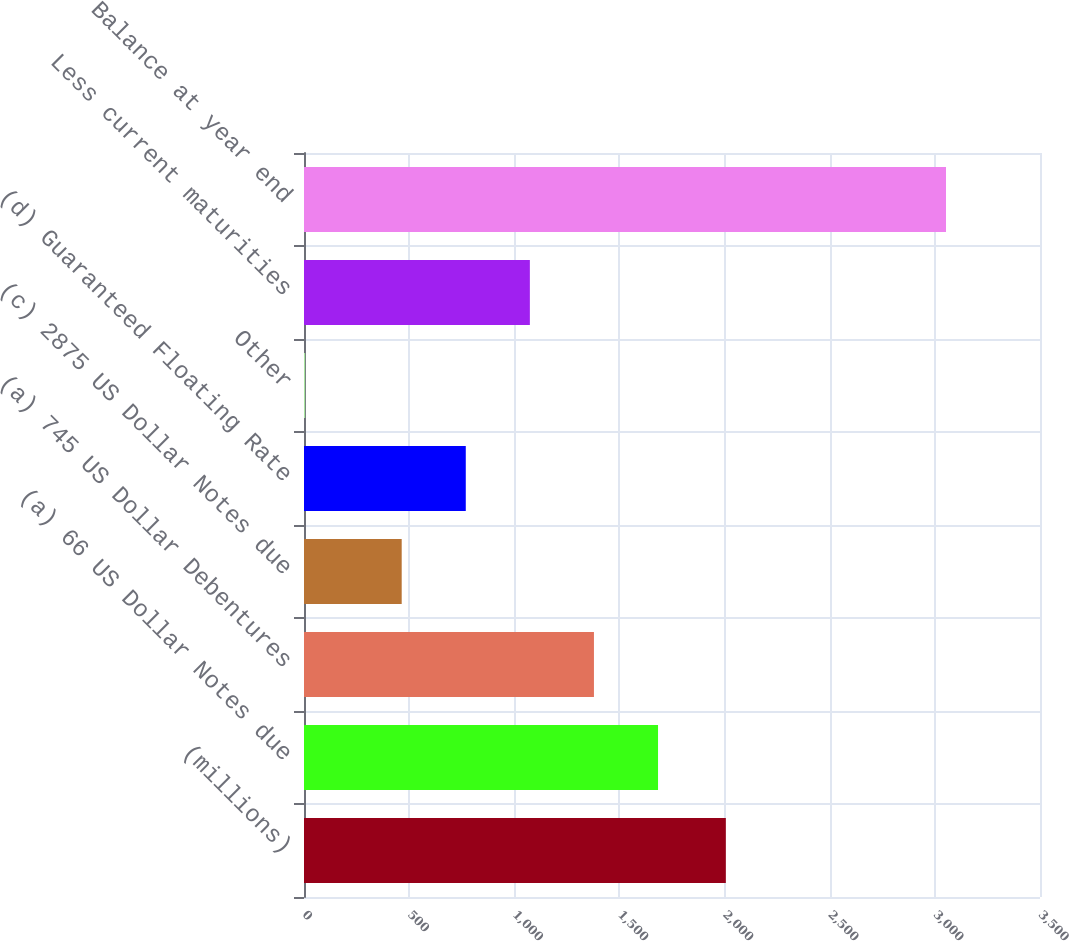Convert chart to OTSL. <chart><loc_0><loc_0><loc_500><loc_500><bar_chart><fcel>(millions)<fcel>(a) 66 US Dollar Notes due<fcel>(a) 745 US Dollar Debentures<fcel>(c) 2875 US Dollar Notes due<fcel>(d) Guaranteed Floating Rate<fcel>Other<fcel>Less current maturities<fcel>Balance at year end<nl><fcel>2006<fcel>1683.56<fcel>1378.82<fcel>464.6<fcel>769.34<fcel>5.6<fcel>1074.08<fcel>3053<nl></chart> 